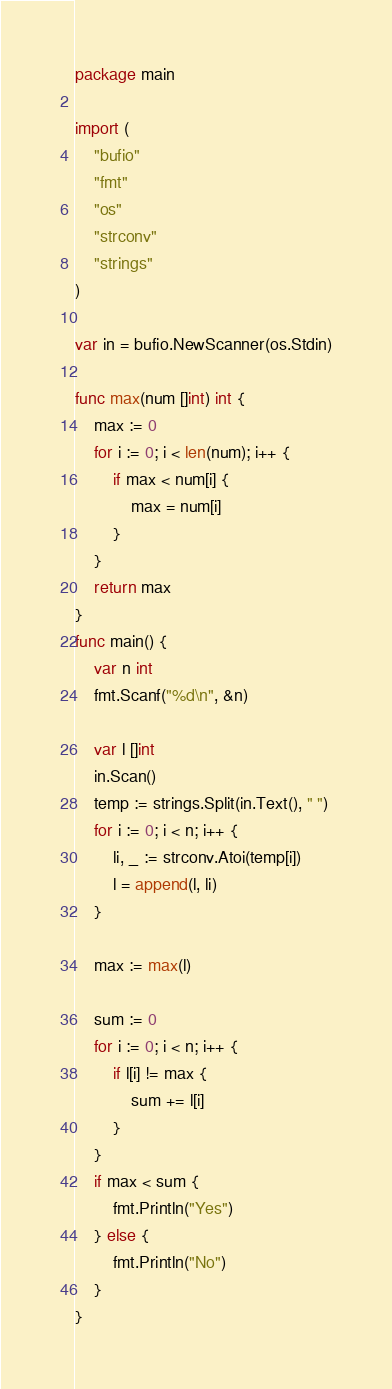Convert code to text. <code><loc_0><loc_0><loc_500><loc_500><_Go_>package main

import (
	"bufio"
	"fmt"
	"os"
	"strconv"
	"strings"
)

var in = bufio.NewScanner(os.Stdin)

func max(num []int) int {
	max := 0
	for i := 0; i < len(num); i++ {
		if max < num[i] {
			max = num[i]
		}
	}
	return max
}
func main() {
	var n int
	fmt.Scanf("%d\n", &n)

	var l []int
	in.Scan()
	temp := strings.Split(in.Text(), " ")
	for i := 0; i < n; i++ {
		li, _ := strconv.Atoi(temp[i])
		l = append(l, li)
	}

	max := max(l)

	sum := 0
	for i := 0; i < n; i++ {
		if l[i] != max {
			sum += l[i]
		}
	}
	if max < sum {
		fmt.Println("Yes")
	} else {
		fmt.Println("No")
	}
}</code> 